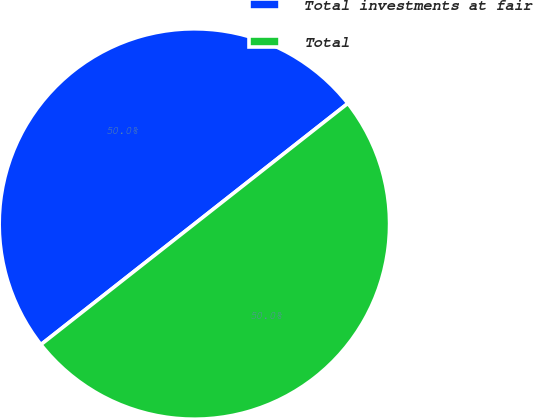<chart> <loc_0><loc_0><loc_500><loc_500><pie_chart><fcel>Total investments at fair<fcel>Total<nl><fcel>50.0%<fcel>50.0%<nl></chart> 